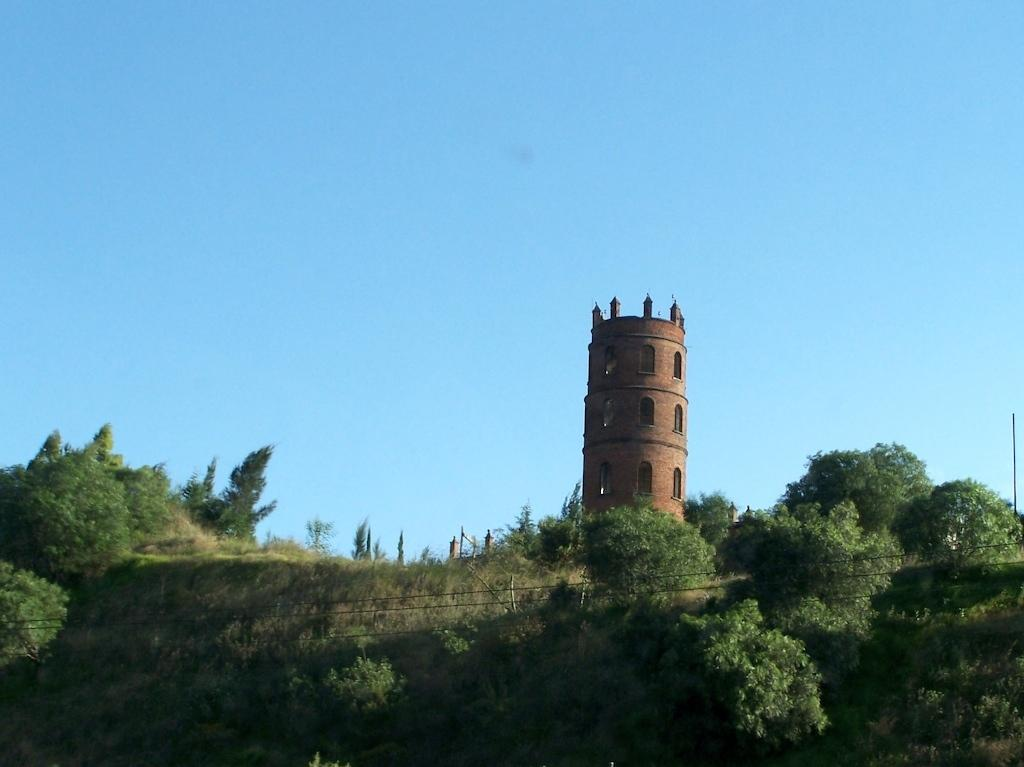What type of vegetation is present in the image? There is grass in the image. What else can be seen in the image besides the grass? There are wires, a group of trees, and a tower visible in the image. What is the background of the image? The sky is visible at the top of the image. What type of polish is being applied to the wires in the image? There is no polish or application process visible in the image; it only shows wires, trees, a tower, and grass. 